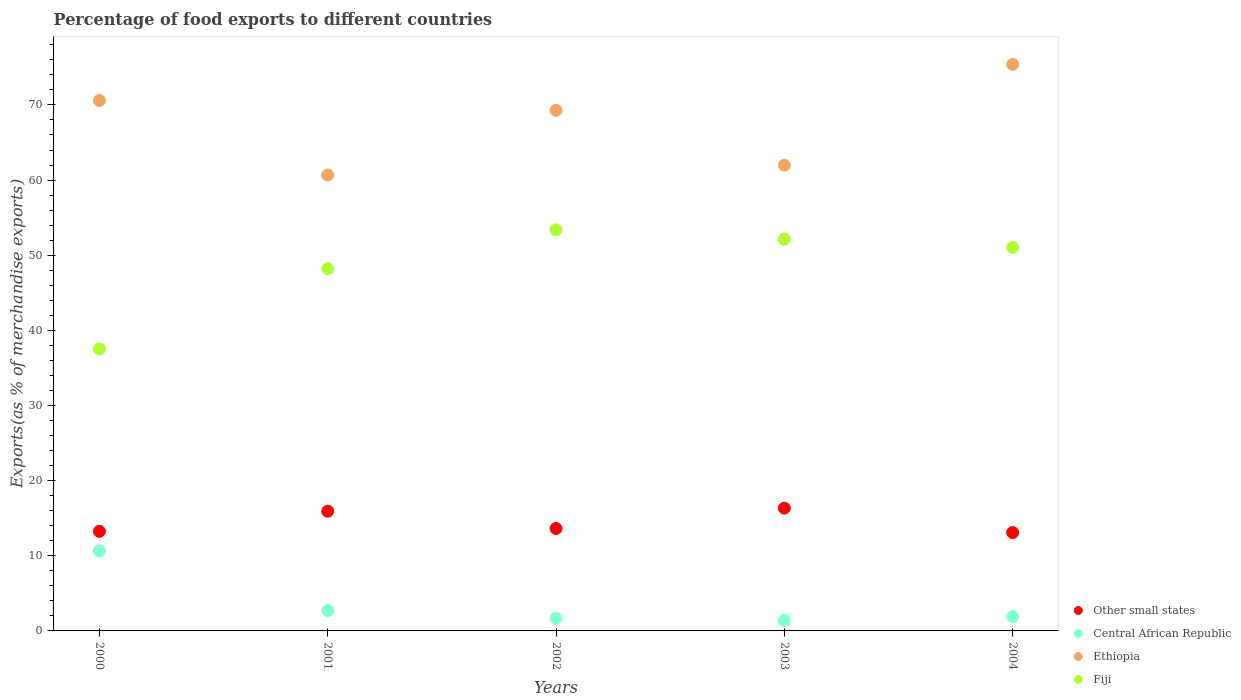What is the percentage of exports to different countries in Central African Republic in 2003?
Make the answer very short. 1.39. Across all years, what is the maximum percentage of exports to different countries in Central African Republic?
Offer a very short reply. 10.65. Across all years, what is the minimum percentage of exports to different countries in Central African Republic?
Offer a terse response. 1.39. In which year was the percentage of exports to different countries in Ethiopia maximum?
Ensure brevity in your answer.  2004. In which year was the percentage of exports to different countries in Central African Republic minimum?
Make the answer very short. 2003. What is the total percentage of exports to different countries in Ethiopia in the graph?
Provide a succinct answer. 337.93. What is the difference between the percentage of exports to different countries in Fiji in 2000 and that in 2001?
Provide a short and direct response. -10.69. What is the difference between the percentage of exports to different countries in Ethiopia in 2003 and the percentage of exports to different countries in Fiji in 2000?
Make the answer very short. 24.46. What is the average percentage of exports to different countries in Central African Republic per year?
Make the answer very short. 3.66. In the year 2004, what is the difference between the percentage of exports to different countries in Other small states and percentage of exports to different countries in Central African Republic?
Your answer should be compact. 11.19. In how many years, is the percentage of exports to different countries in Ethiopia greater than 22 %?
Your answer should be very brief. 5. What is the ratio of the percentage of exports to different countries in Other small states in 2000 to that in 2001?
Offer a terse response. 0.83. Is the percentage of exports to different countries in Other small states in 2001 less than that in 2003?
Keep it short and to the point. Yes. What is the difference between the highest and the second highest percentage of exports to different countries in Fiji?
Your response must be concise. 1.24. What is the difference between the highest and the lowest percentage of exports to different countries in Other small states?
Offer a very short reply. 3.25. Is it the case that in every year, the sum of the percentage of exports to different countries in Central African Republic and percentage of exports to different countries in Fiji  is greater than the sum of percentage of exports to different countries in Other small states and percentage of exports to different countries in Ethiopia?
Offer a terse response. Yes. Is it the case that in every year, the sum of the percentage of exports to different countries in Other small states and percentage of exports to different countries in Ethiopia  is greater than the percentage of exports to different countries in Fiji?
Offer a terse response. Yes. Is the percentage of exports to different countries in Other small states strictly less than the percentage of exports to different countries in Ethiopia over the years?
Make the answer very short. Yes. How many dotlines are there?
Provide a succinct answer. 4. How many years are there in the graph?
Your answer should be very brief. 5. How are the legend labels stacked?
Your answer should be compact. Vertical. What is the title of the graph?
Provide a short and direct response. Percentage of food exports to different countries. Does "Djibouti" appear as one of the legend labels in the graph?
Offer a very short reply. No. What is the label or title of the X-axis?
Make the answer very short. Years. What is the label or title of the Y-axis?
Provide a succinct answer. Exports(as % of merchandise exports). What is the Exports(as % of merchandise exports) of Other small states in 2000?
Provide a short and direct response. 13.26. What is the Exports(as % of merchandise exports) in Central African Republic in 2000?
Make the answer very short. 10.65. What is the Exports(as % of merchandise exports) of Ethiopia in 2000?
Your response must be concise. 70.59. What is the Exports(as % of merchandise exports) in Fiji in 2000?
Give a very brief answer. 37.52. What is the Exports(as % of merchandise exports) in Other small states in 2001?
Your answer should be compact. 15.93. What is the Exports(as % of merchandise exports) in Central African Republic in 2001?
Give a very brief answer. 2.71. What is the Exports(as % of merchandise exports) of Ethiopia in 2001?
Your response must be concise. 60.68. What is the Exports(as % of merchandise exports) of Fiji in 2001?
Offer a very short reply. 48.2. What is the Exports(as % of merchandise exports) in Other small states in 2002?
Your answer should be compact. 13.63. What is the Exports(as % of merchandise exports) in Central African Republic in 2002?
Give a very brief answer. 1.68. What is the Exports(as % of merchandise exports) of Ethiopia in 2002?
Provide a succinct answer. 69.28. What is the Exports(as % of merchandise exports) in Fiji in 2002?
Offer a very short reply. 53.38. What is the Exports(as % of merchandise exports) in Other small states in 2003?
Ensure brevity in your answer.  16.34. What is the Exports(as % of merchandise exports) in Central African Republic in 2003?
Provide a short and direct response. 1.39. What is the Exports(as % of merchandise exports) in Ethiopia in 2003?
Give a very brief answer. 61.98. What is the Exports(as % of merchandise exports) in Fiji in 2003?
Keep it short and to the point. 52.14. What is the Exports(as % of merchandise exports) in Other small states in 2004?
Keep it short and to the point. 13.08. What is the Exports(as % of merchandise exports) in Central African Republic in 2004?
Your response must be concise. 1.89. What is the Exports(as % of merchandise exports) in Ethiopia in 2004?
Your answer should be compact. 75.39. What is the Exports(as % of merchandise exports) of Fiji in 2004?
Your response must be concise. 51.04. Across all years, what is the maximum Exports(as % of merchandise exports) of Other small states?
Provide a succinct answer. 16.34. Across all years, what is the maximum Exports(as % of merchandise exports) of Central African Republic?
Give a very brief answer. 10.65. Across all years, what is the maximum Exports(as % of merchandise exports) in Ethiopia?
Provide a short and direct response. 75.39. Across all years, what is the maximum Exports(as % of merchandise exports) in Fiji?
Keep it short and to the point. 53.38. Across all years, what is the minimum Exports(as % of merchandise exports) of Other small states?
Your answer should be compact. 13.08. Across all years, what is the minimum Exports(as % of merchandise exports) in Central African Republic?
Give a very brief answer. 1.39. Across all years, what is the minimum Exports(as % of merchandise exports) of Ethiopia?
Ensure brevity in your answer.  60.68. Across all years, what is the minimum Exports(as % of merchandise exports) of Fiji?
Offer a very short reply. 37.52. What is the total Exports(as % of merchandise exports) of Other small states in the graph?
Provide a short and direct response. 72.24. What is the total Exports(as % of merchandise exports) of Central African Republic in the graph?
Give a very brief answer. 18.32. What is the total Exports(as % of merchandise exports) in Ethiopia in the graph?
Keep it short and to the point. 337.93. What is the total Exports(as % of merchandise exports) of Fiji in the graph?
Your response must be concise. 242.28. What is the difference between the Exports(as % of merchandise exports) in Other small states in 2000 and that in 2001?
Offer a very short reply. -2.67. What is the difference between the Exports(as % of merchandise exports) of Central African Republic in 2000 and that in 2001?
Your response must be concise. 7.94. What is the difference between the Exports(as % of merchandise exports) of Ethiopia in 2000 and that in 2001?
Make the answer very short. 9.91. What is the difference between the Exports(as % of merchandise exports) in Fiji in 2000 and that in 2001?
Make the answer very short. -10.69. What is the difference between the Exports(as % of merchandise exports) of Other small states in 2000 and that in 2002?
Keep it short and to the point. -0.38. What is the difference between the Exports(as % of merchandise exports) in Central African Republic in 2000 and that in 2002?
Offer a terse response. 8.97. What is the difference between the Exports(as % of merchandise exports) of Ethiopia in 2000 and that in 2002?
Provide a succinct answer. 1.31. What is the difference between the Exports(as % of merchandise exports) of Fiji in 2000 and that in 2002?
Your answer should be very brief. -15.86. What is the difference between the Exports(as % of merchandise exports) of Other small states in 2000 and that in 2003?
Your answer should be very brief. -3.08. What is the difference between the Exports(as % of merchandise exports) of Central African Republic in 2000 and that in 2003?
Make the answer very short. 9.26. What is the difference between the Exports(as % of merchandise exports) in Ethiopia in 2000 and that in 2003?
Your response must be concise. 8.61. What is the difference between the Exports(as % of merchandise exports) in Fiji in 2000 and that in 2003?
Provide a succinct answer. -14.62. What is the difference between the Exports(as % of merchandise exports) of Other small states in 2000 and that in 2004?
Provide a succinct answer. 0.17. What is the difference between the Exports(as % of merchandise exports) of Central African Republic in 2000 and that in 2004?
Your answer should be very brief. 8.76. What is the difference between the Exports(as % of merchandise exports) of Ethiopia in 2000 and that in 2004?
Offer a terse response. -4.8. What is the difference between the Exports(as % of merchandise exports) of Fiji in 2000 and that in 2004?
Your response must be concise. -13.52. What is the difference between the Exports(as % of merchandise exports) of Other small states in 2001 and that in 2002?
Give a very brief answer. 2.3. What is the difference between the Exports(as % of merchandise exports) in Central African Republic in 2001 and that in 2002?
Keep it short and to the point. 1.03. What is the difference between the Exports(as % of merchandise exports) in Ethiopia in 2001 and that in 2002?
Give a very brief answer. -8.6. What is the difference between the Exports(as % of merchandise exports) of Fiji in 2001 and that in 2002?
Give a very brief answer. -5.18. What is the difference between the Exports(as % of merchandise exports) of Other small states in 2001 and that in 2003?
Your response must be concise. -0.41. What is the difference between the Exports(as % of merchandise exports) of Central African Republic in 2001 and that in 2003?
Make the answer very short. 1.33. What is the difference between the Exports(as % of merchandise exports) in Ethiopia in 2001 and that in 2003?
Your answer should be very brief. -1.3. What is the difference between the Exports(as % of merchandise exports) of Fiji in 2001 and that in 2003?
Your response must be concise. -3.93. What is the difference between the Exports(as % of merchandise exports) of Other small states in 2001 and that in 2004?
Make the answer very short. 2.84. What is the difference between the Exports(as % of merchandise exports) in Central African Republic in 2001 and that in 2004?
Give a very brief answer. 0.82. What is the difference between the Exports(as % of merchandise exports) of Ethiopia in 2001 and that in 2004?
Offer a very short reply. -14.71. What is the difference between the Exports(as % of merchandise exports) in Fiji in 2001 and that in 2004?
Provide a short and direct response. -2.84. What is the difference between the Exports(as % of merchandise exports) of Other small states in 2002 and that in 2003?
Keep it short and to the point. -2.71. What is the difference between the Exports(as % of merchandise exports) of Central African Republic in 2002 and that in 2003?
Your answer should be compact. 0.3. What is the difference between the Exports(as % of merchandise exports) in Ethiopia in 2002 and that in 2003?
Give a very brief answer. 7.31. What is the difference between the Exports(as % of merchandise exports) in Fiji in 2002 and that in 2003?
Make the answer very short. 1.24. What is the difference between the Exports(as % of merchandise exports) of Other small states in 2002 and that in 2004?
Provide a succinct answer. 0.55. What is the difference between the Exports(as % of merchandise exports) in Central African Republic in 2002 and that in 2004?
Your answer should be very brief. -0.21. What is the difference between the Exports(as % of merchandise exports) of Ethiopia in 2002 and that in 2004?
Ensure brevity in your answer.  -6.11. What is the difference between the Exports(as % of merchandise exports) of Fiji in 2002 and that in 2004?
Keep it short and to the point. 2.34. What is the difference between the Exports(as % of merchandise exports) in Other small states in 2003 and that in 2004?
Provide a succinct answer. 3.25. What is the difference between the Exports(as % of merchandise exports) of Central African Republic in 2003 and that in 2004?
Your answer should be very brief. -0.51. What is the difference between the Exports(as % of merchandise exports) of Ethiopia in 2003 and that in 2004?
Offer a very short reply. -13.42. What is the difference between the Exports(as % of merchandise exports) of Fiji in 2003 and that in 2004?
Provide a short and direct response. 1.1. What is the difference between the Exports(as % of merchandise exports) in Other small states in 2000 and the Exports(as % of merchandise exports) in Central African Republic in 2001?
Ensure brevity in your answer.  10.54. What is the difference between the Exports(as % of merchandise exports) of Other small states in 2000 and the Exports(as % of merchandise exports) of Ethiopia in 2001?
Offer a terse response. -47.42. What is the difference between the Exports(as % of merchandise exports) in Other small states in 2000 and the Exports(as % of merchandise exports) in Fiji in 2001?
Offer a very short reply. -34.95. What is the difference between the Exports(as % of merchandise exports) in Central African Republic in 2000 and the Exports(as % of merchandise exports) in Ethiopia in 2001?
Offer a terse response. -50.03. What is the difference between the Exports(as % of merchandise exports) of Central African Republic in 2000 and the Exports(as % of merchandise exports) of Fiji in 2001?
Your answer should be very brief. -37.55. What is the difference between the Exports(as % of merchandise exports) of Ethiopia in 2000 and the Exports(as % of merchandise exports) of Fiji in 2001?
Your response must be concise. 22.39. What is the difference between the Exports(as % of merchandise exports) in Other small states in 2000 and the Exports(as % of merchandise exports) in Central African Republic in 2002?
Ensure brevity in your answer.  11.57. What is the difference between the Exports(as % of merchandise exports) of Other small states in 2000 and the Exports(as % of merchandise exports) of Ethiopia in 2002?
Keep it short and to the point. -56.03. What is the difference between the Exports(as % of merchandise exports) of Other small states in 2000 and the Exports(as % of merchandise exports) of Fiji in 2002?
Keep it short and to the point. -40.12. What is the difference between the Exports(as % of merchandise exports) in Central African Republic in 2000 and the Exports(as % of merchandise exports) in Ethiopia in 2002?
Provide a succinct answer. -58.63. What is the difference between the Exports(as % of merchandise exports) in Central African Republic in 2000 and the Exports(as % of merchandise exports) in Fiji in 2002?
Your answer should be very brief. -42.73. What is the difference between the Exports(as % of merchandise exports) of Ethiopia in 2000 and the Exports(as % of merchandise exports) of Fiji in 2002?
Keep it short and to the point. 17.21. What is the difference between the Exports(as % of merchandise exports) in Other small states in 2000 and the Exports(as % of merchandise exports) in Central African Republic in 2003?
Offer a very short reply. 11.87. What is the difference between the Exports(as % of merchandise exports) of Other small states in 2000 and the Exports(as % of merchandise exports) of Ethiopia in 2003?
Offer a terse response. -48.72. What is the difference between the Exports(as % of merchandise exports) in Other small states in 2000 and the Exports(as % of merchandise exports) in Fiji in 2003?
Provide a short and direct response. -38.88. What is the difference between the Exports(as % of merchandise exports) in Central African Republic in 2000 and the Exports(as % of merchandise exports) in Ethiopia in 2003?
Offer a terse response. -51.33. What is the difference between the Exports(as % of merchandise exports) of Central African Republic in 2000 and the Exports(as % of merchandise exports) of Fiji in 2003?
Ensure brevity in your answer.  -41.49. What is the difference between the Exports(as % of merchandise exports) of Ethiopia in 2000 and the Exports(as % of merchandise exports) of Fiji in 2003?
Your answer should be compact. 18.46. What is the difference between the Exports(as % of merchandise exports) of Other small states in 2000 and the Exports(as % of merchandise exports) of Central African Republic in 2004?
Your answer should be very brief. 11.37. What is the difference between the Exports(as % of merchandise exports) in Other small states in 2000 and the Exports(as % of merchandise exports) in Ethiopia in 2004?
Make the answer very short. -62.14. What is the difference between the Exports(as % of merchandise exports) in Other small states in 2000 and the Exports(as % of merchandise exports) in Fiji in 2004?
Ensure brevity in your answer.  -37.78. What is the difference between the Exports(as % of merchandise exports) in Central African Republic in 2000 and the Exports(as % of merchandise exports) in Ethiopia in 2004?
Offer a terse response. -64.74. What is the difference between the Exports(as % of merchandise exports) in Central African Republic in 2000 and the Exports(as % of merchandise exports) in Fiji in 2004?
Make the answer very short. -40.39. What is the difference between the Exports(as % of merchandise exports) in Ethiopia in 2000 and the Exports(as % of merchandise exports) in Fiji in 2004?
Provide a succinct answer. 19.55. What is the difference between the Exports(as % of merchandise exports) of Other small states in 2001 and the Exports(as % of merchandise exports) of Central African Republic in 2002?
Provide a short and direct response. 14.25. What is the difference between the Exports(as % of merchandise exports) of Other small states in 2001 and the Exports(as % of merchandise exports) of Ethiopia in 2002?
Provide a short and direct response. -53.35. What is the difference between the Exports(as % of merchandise exports) of Other small states in 2001 and the Exports(as % of merchandise exports) of Fiji in 2002?
Your answer should be very brief. -37.45. What is the difference between the Exports(as % of merchandise exports) of Central African Republic in 2001 and the Exports(as % of merchandise exports) of Ethiopia in 2002?
Your answer should be compact. -66.57. What is the difference between the Exports(as % of merchandise exports) in Central African Republic in 2001 and the Exports(as % of merchandise exports) in Fiji in 2002?
Provide a short and direct response. -50.66. What is the difference between the Exports(as % of merchandise exports) in Ethiopia in 2001 and the Exports(as % of merchandise exports) in Fiji in 2002?
Ensure brevity in your answer.  7.3. What is the difference between the Exports(as % of merchandise exports) of Other small states in 2001 and the Exports(as % of merchandise exports) of Central African Republic in 2003?
Offer a very short reply. 14.54. What is the difference between the Exports(as % of merchandise exports) in Other small states in 2001 and the Exports(as % of merchandise exports) in Ethiopia in 2003?
Provide a short and direct response. -46.05. What is the difference between the Exports(as % of merchandise exports) in Other small states in 2001 and the Exports(as % of merchandise exports) in Fiji in 2003?
Offer a terse response. -36.21. What is the difference between the Exports(as % of merchandise exports) of Central African Republic in 2001 and the Exports(as % of merchandise exports) of Ethiopia in 2003?
Provide a succinct answer. -59.26. What is the difference between the Exports(as % of merchandise exports) of Central African Republic in 2001 and the Exports(as % of merchandise exports) of Fiji in 2003?
Your response must be concise. -49.42. What is the difference between the Exports(as % of merchandise exports) of Ethiopia in 2001 and the Exports(as % of merchandise exports) of Fiji in 2003?
Your response must be concise. 8.54. What is the difference between the Exports(as % of merchandise exports) of Other small states in 2001 and the Exports(as % of merchandise exports) of Central African Republic in 2004?
Your answer should be compact. 14.04. What is the difference between the Exports(as % of merchandise exports) of Other small states in 2001 and the Exports(as % of merchandise exports) of Ethiopia in 2004?
Your response must be concise. -59.46. What is the difference between the Exports(as % of merchandise exports) in Other small states in 2001 and the Exports(as % of merchandise exports) in Fiji in 2004?
Offer a terse response. -35.11. What is the difference between the Exports(as % of merchandise exports) of Central African Republic in 2001 and the Exports(as % of merchandise exports) of Ethiopia in 2004?
Provide a succinct answer. -72.68. What is the difference between the Exports(as % of merchandise exports) of Central African Republic in 2001 and the Exports(as % of merchandise exports) of Fiji in 2004?
Give a very brief answer. -48.32. What is the difference between the Exports(as % of merchandise exports) in Ethiopia in 2001 and the Exports(as % of merchandise exports) in Fiji in 2004?
Keep it short and to the point. 9.64. What is the difference between the Exports(as % of merchandise exports) in Other small states in 2002 and the Exports(as % of merchandise exports) in Central African Republic in 2003?
Provide a succinct answer. 12.25. What is the difference between the Exports(as % of merchandise exports) of Other small states in 2002 and the Exports(as % of merchandise exports) of Ethiopia in 2003?
Provide a short and direct response. -48.34. What is the difference between the Exports(as % of merchandise exports) of Other small states in 2002 and the Exports(as % of merchandise exports) of Fiji in 2003?
Ensure brevity in your answer.  -38.5. What is the difference between the Exports(as % of merchandise exports) of Central African Republic in 2002 and the Exports(as % of merchandise exports) of Ethiopia in 2003?
Provide a short and direct response. -60.3. What is the difference between the Exports(as % of merchandise exports) in Central African Republic in 2002 and the Exports(as % of merchandise exports) in Fiji in 2003?
Give a very brief answer. -50.46. What is the difference between the Exports(as % of merchandise exports) in Ethiopia in 2002 and the Exports(as % of merchandise exports) in Fiji in 2003?
Provide a succinct answer. 17.15. What is the difference between the Exports(as % of merchandise exports) of Other small states in 2002 and the Exports(as % of merchandise exports) of Central African Republic in 2004?
Your answer should be compact. 11.74. What is the difference between the Exports(as % of merchandise exports) of Other small states in 2002 and the Exports(as % of merchandise exports) of Ethiopia in 2004?
Make the answer very short. -61.76. What is the difference between the Exports(as % of merchandise exports) of Other small states in 2002 and the Exports(as % of merchandise exports) of Fiji in 2004?
Offer a terse response. -37.41. What is the difference between the Exports(as % of merchandise exports) of Central African Republic in 2002 and the Exports(as % of merchandise exports) of Ethiopia in 2004?
Your response must be concise. -73.71. What is the difference between the Exports(as % of merchandise exports) of Central African Republic in 2002 and the Exports(as % of merchandise exports) of Fiji in 2004?
Make the answer very short. -49.36. What is the difference between the Exports(as % of merchandise exports) in Ethiopia in 2002 and the Exports(as % of merchandise exports) in Fiji in 2004?
Provide a short and direct response. 18.24. What is the difference between the Exports(as % of merchandise exports) of Other small states in 2003 and the Exports(as % of merchandise exports) of Central African Republic in 2004?
Make the answer very short. 14.45. What is the difference between the Exports(as % of merchandise exports) in Other small states in 2003 and the Exports(as % of merchandise exports) in Ethiopia in 2004?
Provide a short and direct response. -59.05. What is the difference between the Exports(as % of merchandise exports) in Other small states in 2003 and the Exports(as % of merchandise exports) in Fiji in 2004?
Give a very brief answer. -34.7. What is the difference between the Exports(as % of merchandise exports) in Central African Republic in 2003 and the Exports(as % of merchandise exports) in Ethiopia in 2004?
Your answer should be very brief. -74.01. What is the difference between the Exports(as % of merchandise exports) in Central African Republic in 2003 and the Exports(as % of merchandise exports) in Fiji in 2004?
Your answer should be compact. -49.65. What is the difference between the Exports(as % of merchandise exports) in Ethiopia in 2003 and the Exports(as % of merchandise exports) in Fiji in 2004?
Give a very brief answer. 10.94. What is the average Exports(as % of merchandise exports) of Other small states per year?
Your response must be concise. 14.45. What is the average Exports(as % of merchandise exports) in Central African Republic per year?
Ensure brevity in your answer.  3.66. What is the average Exports(as % of merchandise exports) of Ethiopia per year?
Give a very brief answer. 67.59. What is the average Exports(as % of merchandise exports) in Fiji per year?
Offer a very short reply. 48.46. In the year 2000, what is the difference between the Exports(as % of merchandise exports) of Other small states and Exports(as % of merchandise exports) of Central African Republic?
Your answer should be very brief. 2.61. In the year 2000, what is the difference between the Exports(as % of merchandise exports) of Other small states and Exports(as % of merchandise exports) of Ethiopia?
Give a very brief answer. -57.34. In the year 2000, what is the difference between the Exports(as % of merchandise exports) of Other small states and Exports(as % of merchandise exports) of Fiji?
Your answer should be compact. -24.26. In the year 2000, what is the difference between the Exports(as % of merchandise exports) of Central African Republic and Exports(as % of merchandise exports) of Ethiopia?
Offer a terse response. -59.94. In the year 2000, what is the difference between the Exports(as % of merchandise exports) in Central African Republic and Exports(as % of merchandise exports) in Fiji?
Give a very brief answer. -26.87. In the year 2000, what is the difference between the Exports(as % of merchandise exports) in Ethiopia and Exports(as % of merchandise exports) in Fiji?
Provide a short and direct response. 33.08. In the year 2001, what is the difference between the Exports(as % of merchandise exports) of Other small states and Exports(as % of merchandise exports) of Central African Republic?
Keep it short and to the point. 13.21. In the year 2001, what is the difference between the Exports(as % of merchandise exports) of Other small states and Exports(as % of merchandise exports) of Ethiopia?
Keep it short and to the point. -44.75. In the year 2001, what is the difference between the Exports(as % of merchandise exports) of Other small states and Exports(as % of merchandise exports) of Fiji?
Your response must be concise. -32.27. In the year 2001, what is the difference between the Exports(as % of merchandise exports) in Central African Republic and Exports(as % of merchandise exports) in Ethiopia?
Offer a terse response. -57.97. In the year 2001, what is the difference between the Exports(as % of merchandise exports) in Central African Republic and Exports(as % of merchandise exports) in Fiji?
Keep it short and to the point. -45.49. In the year 2001, what is the difference between the Exports(as % of merchandise exports) in Ethiopia and Exports(as % of merchandise exports) in Fiji?
Keep it short and to the point. 12.48. In the year 2002, what is the difference between the Exports(as % of merchandise exports) of Other small states and Exports(as % of merchandise exports) of Central African Republic?
Offer a terse response. 11.95. In the year 2002, what is the difference between the Exports(as % of merchandise exports) of Other small states and Exports(as % of merchandise exports) of Ethiopia?
Ensure brevity in your answer.  -55.65. In the year 2002, what is the difference between the Exports(as % of merchandise exports) of Other small states and Exports(as % of merchandise exports) of Fiji?
Make the answer very short. -39.75. In the year 2002, what is the difference between the Exports(as % of merchandise exports) in Central African Republic and Exports(as % of merchandise exports) in Ethiopia?
Your answer should be compact. -67.6. In the year 2002, what is the difference between the Exports(as % of merchandise exports) in Central African Republic and Exports(as % of merchandise exports) in Fiji?
Your response must be concise. -51.7. In the year 2002, what is the difference between the Exports(as % of merchandise exports) in Ethiopia and Exports(as % of merchandise exports) in Fiji?
Give a very brief answer. 15.9. In the year 2003, what is the difference between the Exports(as % of merchandise exports) of Other small states and Exports(as % of merchandise exports) of Central African Republic?
Ensure brevity in your answer.  14.95. In the year 2003, what is the difference between the Exports(as % of merchandise exports) of Other small states and Exports(as % of merchandise exports) of Ethiopia?
Give a very brief answer. -45.64. In the year 2003, what is the difference between the Exports(as % of merchandise exports) in Other small states and Exports(as % of merchandise exports) in Fiji?
Offer a very short reply. -35.8. In the year 2003, what is the difference between the Exports(as % of merchandise exports) in Central African Republic and Exports(as % of merchandise exports) in Ethiopia?
Your answer should be very brief. -60.59. In the year 2003, what is the difference between the Exports(as % of merchandise exports) in Central African Republic and Exports(as % of merchandise exports) in Fiji?
Keep it short and to the point. -50.75. In the year 2003, what is the difference between the Exports(as % of merchandise exports) of Ethiopia and Exports(as % of merchandise exports) of Fiji?
Your answer should be very brief. 9.84. In the year 2004, what is the difference between the Exports(as % of merchandise exports) in Other small states and Exports(as % of merchandise exports) in Central African Republic?
Offer a very short reply. 11.19. In the year 2004, what is the difference between the Exports(as % of merchandise exports) of Other small states and Exports(as % of merchandise exports) of Ethiopia?
Give a very brief answer. -62.31. In the year 2004, what is the difference between the Exports(as % of merchandise exports) of Other small states and Exports(as % of merchandise exports) of Fiji?
Your response must be concise. -37.95. In the year 2004, what is the difference between the Exports(as % of merchandise exports) of Central African Republic and Exports(as % of merchandise exports) of Ethiopia?
Provide a short and direct response. -73.5. In the year 2004, what is the difference between the Exports(as % of merchandise exports) of Central African Republic and Exports(as % of merchandise exports) of Fiji?
Make the answer very short. -49.15. In the year 2004, what is the difference between the Exports(as % of merchandise exports) in Ethiopia and Exports(as % of merchandise exports) in Fiji?
Your answer should be very brief. 24.35. What is the ratio of the Exports(as % of merchandise exports) of Other small states in 2000 to that in 2001?
Offer a very short reply. 0.83. What is the ratio of the Exports(as % of merchandise exports) in Central African Republic in 2000 to that in 2001?
Provide a short and direct response. 3.92. What is the ratio of the Exports(as % of merchandise exports) in Ethiopia in 2000 to that in 2001?
Ensure brevity in your answer.  1.16. What is the ratio of the Exports(as % of merchandise exports) of Fiji in 2000 to that in 2001?
Make the answer very short. 0.78. What is the ratio of the Exports(as % of merchandise exports) in Other small states in 2000 to that in 2002?
Your answer should be very brief. 0.97. What is the ratio of the Exports(as % of merchandise exports) of Central African Republic in 2000 to that in 2002?
Make the answer very short. 6.33. What is the ratio of the Exports(as % of merchandise exports) in Ethiopia in 2000 to that in 2002?
Ensure brevity in your answer.  1.02. What is the ratio of the Exports(as % of merchandise exports) of Fiji in 2000 to that in 2002?
Make the answer very short. 0.7. What is the ratio of the Exports(as % of merchandise exports) of Other small states in 2000 to that in 2003?
Your answer should be compact. 0.81. What is the ratio of the Exports(as % of merchandise exports) in Central African Republic in 2000 to that in 2003?
Your answer should be compact. 7.69. What is the ratio of the Exports(as % of merchandise exports) in Ethiopia in 2000 to that in 2003?
Your answer should be very brief. 1.14. What is the ratio of the Exports(as % of merchandise exports) in Fiji in 2000 to that in 2003?
Make the answer very short. 0.72. What is the ratio of the Exports(as % of merchandise exports) in Other small states in 2000 to that in 2004?
Offer a terse response. 1.01. What is the ratio of the Exports(as % of merchandise exports) in Central African Republic in 2000 to that in 2004?
Ensure brevity in your answer.  5.63. What is the ratio of the Exports(as % of merchandise exports) of Ethiopia in 2000 to that in 2004?
Offer a very short reply. 0.94. What is the ratio of the Exports(as % of merchandise exports) of Fiji in 2000 to that in 2004?
Make the answer very short. 0.73. What is the ratio of the Exports(as % of merchandise exports) in Other small states in 2001 to that in 2002?
Make the answer very short. 1.17. What is the ratio of the Exports(as % of merchandise exports) of Central African Republic in 2001 to that in 2002?
Your response must be concise. 1.61. What is the ratio of the Exports(as % of merchandise exports) of Ethiopia in 2001 to that in 2002?
Ensure brevity in your answer.  0.88. What is the ratio of the Exports(as % of merchandise exports) of Fiji in 2001 to that in 2002?
Offer a very short reply. 0.9. What is the ratio of the Exports(as % of merchandise exports) of Other small states in 2001 to that in 2003?
Provide a succinct answer. 0.97. What is the ratio of the Exports(as % of merchandise exports) of Central African Republic in 2001 to that in 2003?
Your response must be concise. 1.96. What is the ratio of the Exports(as % of merchandise exports) of Ethiopia in 2001 to that in 2003?
Ensure brevity in your answer.  0.98. What is the ratio of the Exports(as % of merchandise exports) in Fiji in 2001 to that in 2003?
Your answer should be very brief. 0.92. What is the ratio of the Exports(as % of merchandise exports) in Other small states in 2001 to that in 2004?
Your response must be concise. 1.22. What is the ratio of the Exports(as % of merchandise exports) of Central African Republic in 2001 to that in 2004?
Your answer should be very brief. 1.44. What is the ratio of the Exports(as % of merchandise exports) of Ethiopia in 2001 to that in 2004?
Provide a succinct answer. 0.8. What is the ratio of the Exports(as % of merchandise exports) in Other small states in 2002 to that in 2003?
Offer a terse response. 0.83. What is the ratio of the Exports(as % of merchandise exports) in Central African Republic in 2002 to that in 2003?
Make the answer very short. 1.21. What is the ratio of the Exports(as % of merchandise exports) in Ethiopia in 2002 to that in 2003?
Offer a terse response. 1.12. What is the ratio of the Exports(as % of merchandise exports) of Fiji in 2002 to that in 2003?
Give a very brief answer. 1.02. What is the ratio of the Exports(as % of merchandise exports) of Other small states in 2002 to that in 2004?
Ensure brevity in your answer.  1.04. What is the ratio of the Exports(as % of merchandise exports) of Central African Republic in 2002 to that in 2004?
Ensure brevity in your answer.  0.89. What is the ratio of the Exports(as % of merchandise exports) in Ethiopia in 2002 to that in 2004?
Offer a very short reply. 0.92. What is the ratio of the Exports(as % of merchandise exports) of Fiji in 2002 to that in 2004?
Provide a short and direct response. 1.05. What is the ratio of the Exports(as % of merchandise exports) in Other small states in 2003 to that in 2004?
Offer a very short reply. 1.25. What is the ratio of the Exports(as % of merchandise exports) in Central African Republic in 2003 to that in 2004?
Offer a terse response. 0.73. What is the ratio of the Exports(as % of merchandise exports) in Ethiopia in 2003 to that in 2004?
Provide a short and direct response. 0.82. What is the ratio of the Exports(as % of merchandise exports) of Fiji in 2003 to that in 2004?
Offer a very short reply. 1.02. What is the difference between the highest and the second highest Exports(as % of merchandise exports) of Other small states?
Give a very brief answer. 0.41. What is the difference between the highest and the second highest Exports(as % of merchandise exports) of Central African Republic?
Your answer should be very brief. 7.94. What is the difference between the highest and the second highest Exports(as % of merchandise exports) in Ethiopia?
Provide a short and direct response. 4.8. What is the difference between the highest and the second highest Exports(as % of merchandise exports) in Fiji?
Make the answer very short. 1.24. What is the difference between the highest and the lowest Exports(as % of merchandise exports) of Other small states?
Offer a very short reply. 3.25. What is the difference between the highest and the lowest Exports(as % of merchandise exports) in Central African Republic?
Give a very brief answer. 9.26. What is the difference between the highest and the lowest Exports(as % of merchandise exports) in Ethiopia?
Offer a terse response. 14.71. What is the difference between the highest and the lowest Exports(as % of merchandise exports) in Fiji?
Your answer should be compact. 15.86. 